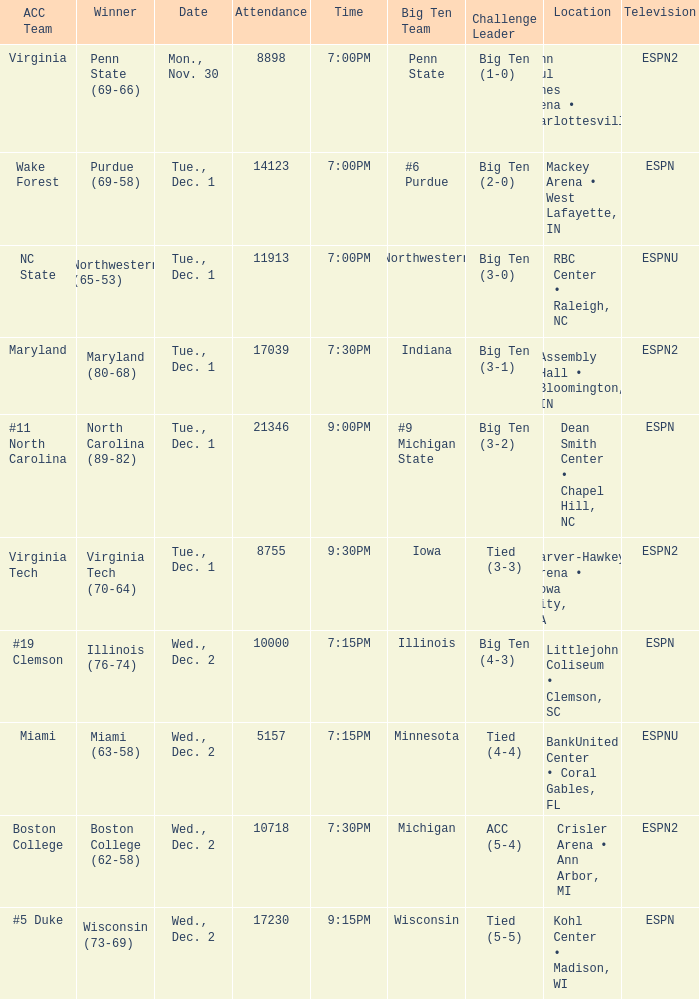Name the location for illinois Littlejohn Coliseum • Clemson, SC. 